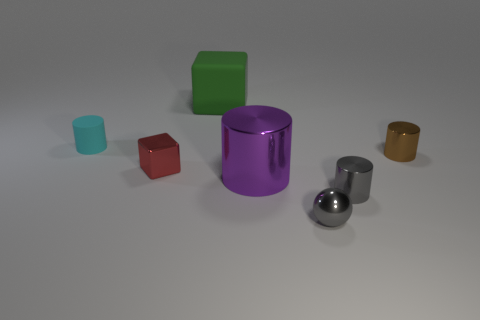What number of big green objects are the same shape as the red thing?
Your response must be concise. 1. What number of cubes are there?
Your response must be concise. 2. The big object in front of the small cyan cylinder is what color?
Offer a very short reply. Purple. There is a rubber thing that is on the left side of the object behind the tiny cyan rubber object; what is its color?
Your answer should be very brief. Cyan. There is a shiny ball that is the same size as the red metal object; what is its color?
Provide a short and direct response. Gray. What number of tiny cylinders are both in front of the brown cylinder and to the left of the tiny gray ball?
Your response must be concise. 0. What is the shape of the small shiny thing that is the same color as the small ball?
Provide a succinct answer. Cylinder. The cylinder that is both right of the tiny cyan cylinder and left of the gray cylinder is made of what material?
Provide a succinct answer. Metal. Is the number of tiny red things to the right of the small gray cylinder less than the number of big rubber blocks behind the rubber cube?
Keep it short and to the point. No. What size is the brown object that is made of the same material as the red object?
Provide a succinct answer. Small. 